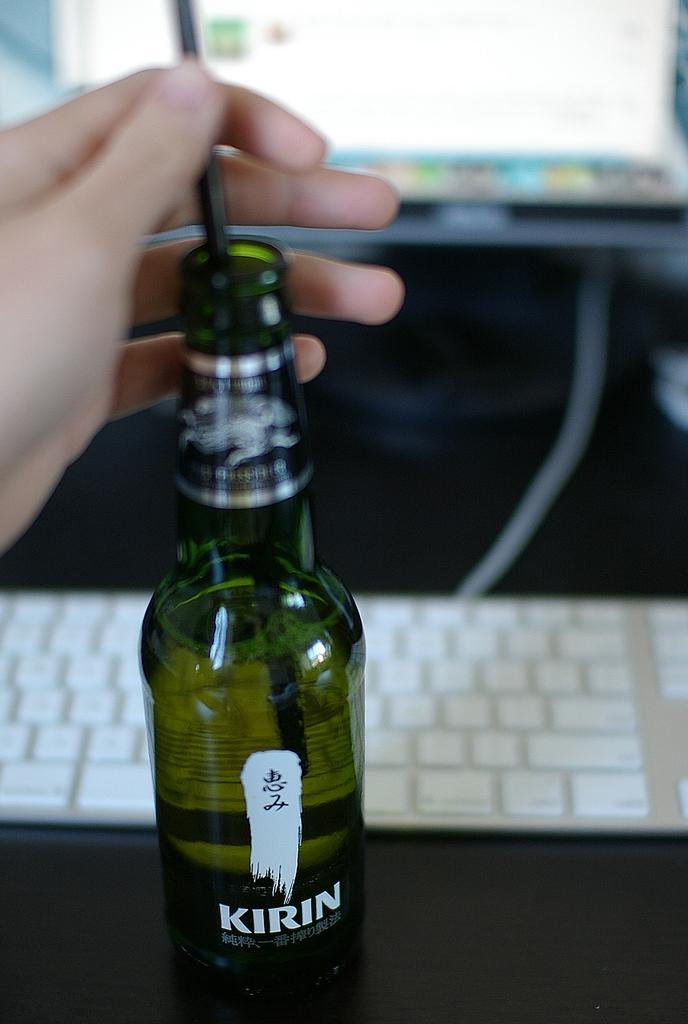<image>
Render a clear and concise summary of the photo. A person putting a straw in a bottle of Kirin beer. 